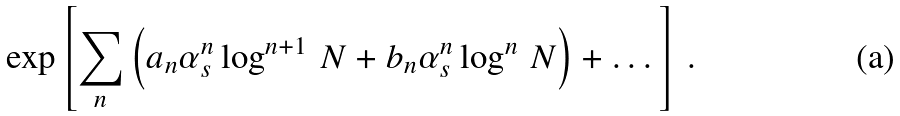Convert formula to latex. <formula><loc_0><loc_0><loc_500><loc_500>\exp \left [ \sum _ { n } \left ( a _ { n } \alpha _ { s } ^ { n } \log ^ { n + 1 } \, N + b _ { n } \alpha _ { s } ^ { n } \log ^ { n } \, N \right ) + \dots \right ] \, .</formula> 